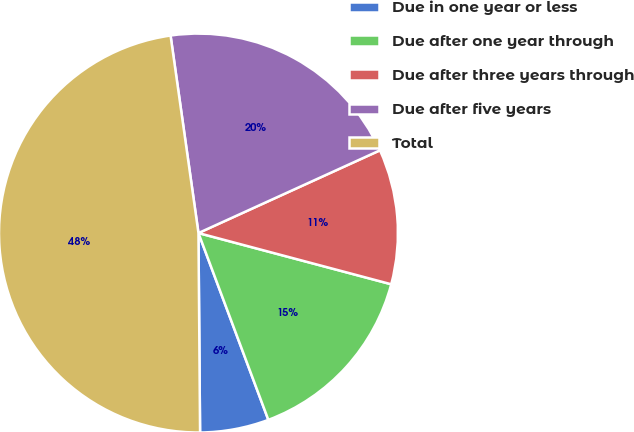Convert chart to OTSL. <chart><loc_0><loc_0><loc_500><loc_500><pie_chart><fcel>Due in one year or less<fcel>Due after one year through<fcel>Due after three years through<fcel>Due after five years<fcel>Total<nl><fcel>5.57%<fcel>15.17%<fcel>10.94%<fcel>20.43%<fcel>47.9%<nl></chart> 